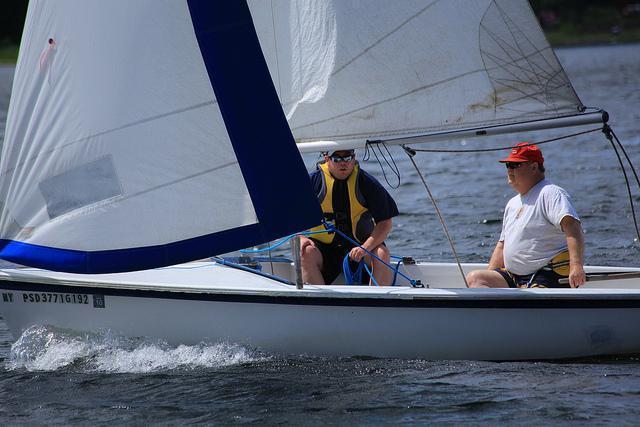How many people are in the picture?
Give a very brief answer. 2. 